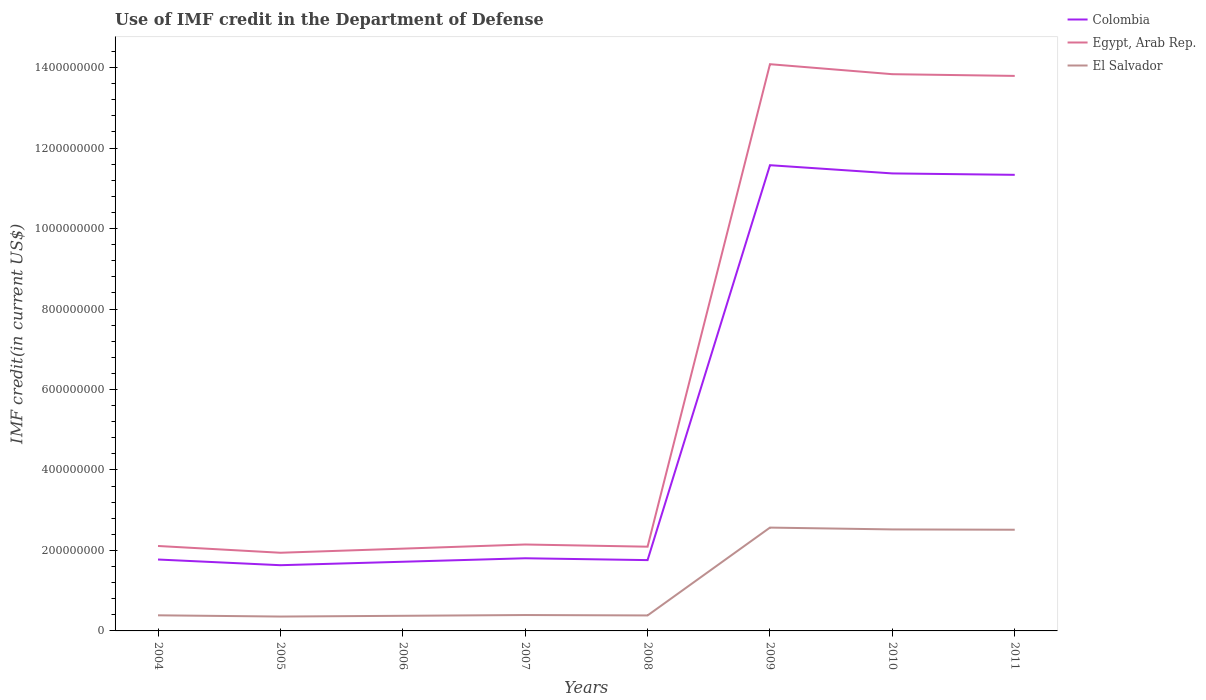Across all years, what is the maximum IMF credit in the Department of Defense in Colombia?
Make the answer very short. 1.63e+08. What is the total IMF credit in the Department of Defense in Egypt, Arab Rep. in the graph?
Offer a terse response. -4.88e+06. What is the difference between the highest and the second highest IMF credit in the Department of Defense in El Salvador?
Provide a short and direct response. 2.21e+08. Is the IMF credit in the Department of Defense in El Salvador strictly greater than the IMF credit in the Department of Defense in Egypt, Arab Rep. over the years?
Your answer should be compact. Yes. How many years are there in the graph?
Keep it short and to the point. 8. What is the difference between two consecutive major ticks on the Y-axis?
Make the answer very short. 2.00e+08. Does the graph contain any zero values?
Ensure brevity in your answer.  No. Does the graph contain grids?
Make the answer very short. No. What is the title of the graph?
Your answer should be very brief. Use of IMF credit in the Department of Defense. What is the label or title of the X-axis?
Your answer should be very brief. Years. What is the label or title of the Y-axis?
Offer a very short reply. IMF credit(in current US$). What is the IMF credit(in current US$) in Colombia in 2004?
Provide a succinct answer. 1.77e+08. What is the IMF credit(in current US$) of Egypt, Arab Rep. in 2004?
Your response must be concise. 2.11e+08. What is the IMF credit(in current US$) in El Salvador in 2004?
Offer a very short reply. 3.88e+07. What is the IMF credit(in current US$) in Colombia in 2005?
Your answer should be very brief. 1.63e+08. What is the IMF credit(in current US$) of Egypt, Arab Rep. in 2005?
Provide a short and direct response. 1.94e+08. What is the IMF credit(in current US$) of El Salvador in 2005?
Your response must be concise. 3.57e+07. What is the IMF credit(in current US$) of Colombia in 2006?
Your answer should be compact. 1.72e+08. What is the IMF credit(in current US$) of Egypt, Arab Rep. in 2006?
Offer a terse response. 2.04e+08. What is the IMF credit(in current US$) in El Salvador in 2006?
Provide a succinct answer. 3.76e+07. What is the IMF credit(in current US$) of Colombia in 2007?
Offer a terse response. 1.81e+08. What is the IMF credit(in current US$) of Egypt, Arab Rep. in 2007?
Your answer should be compact. 2.15e+08. What is the IMF credit(in current US$) of El Salvador in 2007?
Offer a very short reply. 3.95e+07. What is the IMF credit(in current US$) in Colombia in 2008?
Ensure brevity in your answer.  1.76e+08. What is the IMF credit(in current US$) of Egypt, Arab Rep. in 2008?
Offer a very short reply. 2.09e+08. What is the IMF credit(in current US$) of El Salvador in 2008?
Your answer should be very brief. 3.85e+07. What is the IMF credit(in current US$) of Colombia in 2009?
Ensure brevity in your answer.  1.16e+09. What is the IMF credit(in current US$) of Egypt, Arab Rep. in 2009?
Ensure brevity in your answer.  1.41e+09. What is the IMF credit(in current US$) of El Salvador in 2009?
Provide a succinct answer. 2.57e+08. What is the IMF credit(in current US$) of Colombia in 2010?
Your answer should be compact. 1.14e+09. What is the IMF credit(in current US$) in Egypt, Arab Rep. in 2010?
Make the answer very short. 1.38e+09. What is the IMF credit(in current US$) in El Salvador in 2010?
Give a very brief answer. 2.52e+08. What is the IMF credit(in current US$) of Colombia in 2011?
Keep it short and to the point. 1.13e+09. What is the IMF credit(in current US$) in Egypt, Arab Rep. in 2011?
Provide a short and direct response. 1.38e+09. What is the IMF credit(in current US$) of El Salvador in 2011?
Offer a terse response. 2.51e+08. Across all years, what is the maximum IMF credit(in current US$) of Colombia?
Ensure brevity in your answer.  1.16e+09. Across all years, what is the maximum IMF credit(in current US$) of Egypt, Arab Rep.?
Make the answer very short. 1.41e+09. Across all years, what is the maximum IMF credit(in current US$) of El Salvador?
Ensure brevity in your answer.  2.57e+08. Across all years, what is the minimum IMF credit(in current US$) of Colombia?
Make the answer very short. 1.63e+08. Across all years, what is the minimum IMF credit(in current US$) in Egypt, Arab Rep.?
Provide a short and direct response. 1.94e+08. Across all years, what is the minimum IMF credit(in current US$) in El Salvador?
Your answer should be compact. 3.57e+07. What is the total IMF credit(in current US$) in Colombia in the graph?
Provide a succinct answer. 4.30e+09. What is the total IMF credit(in current US$) in Egypt, Arab Rep. in the graph?
Your answer should be very brief. 5.21e+09. What is the total IMF credit(in current US$) in El Salvador in the graph?
Your answer should be compact. 9.51e+08. What is the difference between the IMF credit(in current US$) of Colombia in 2004 and that in 2005?
Give a very brief answer. 1.41e+07. What is the difference between the IMF credit(in current US$) in Egypt, Arab Rep. in 2004 and that in 2005?
Your answer should be compact. 1.68e+07. What is the difference between the IMF credit(in current US$) of El Salvador in 2004 and that in 2005?
Your answer should be compact. 3.09e+06. What is the difference between the IMF credit(in current US$) of Colombia in 2004 and that in 2006?
Ensure brevity in your answer.  5.56e+06. What is the difference between the IMF credit(in current US$) in Egypt, Arab Rep. in 2004 and that in 2006?
Provide a succinct answer. 6.61e+06. What is the difference between the IMF credit(in current US$) in El Salvador in 2004 and that in 2006?
Keep it short and to the point. 1.22e+06. What is the difference between the IMF credit(in current US$) in Colombia in 2004 and that in 2007?
Provide a short and direct response. -3.11e+06. What is the difference between the IMF credit(in current US$) of Egypt, Arab Rep. in 2004 and that in 2007?
Your answer should be very brief. -3.70e+06. What is the difference between the IMF credit(in current US$) of El Salvador in 2004 and that in 2007?
Give a very brief answer. -6.81e+05. What is the difference between the IMF credit(in current US$) of Colombia in 2004 and that in 2008?
Provide a short and direct response. 1.46e+06. What is the difference between the IMF credit(in current US$) of Egypt, Arab Rep. in 2004 and that in 2008?
Ensure brevity in your answer.  1.73e+06. What is the difference between the IMF credit(in current US$) in El Salvador in 2004 and that in 2008?
Ensure brevity in your answer.  3.18e+05. What is the difference between the IMF credit(in current US$) in Colombia in 2004 and that in 2009?
Make the answer very short. -9.80e+08. What is the difference between the IMF credit(in current US$) of Egypt, Arab Rep. in 2004 and that in 2009?
Offer a very short reply. -1.20e+09. What is the difference between the IMF credit(in current US$) in El Salvador in 2004 and that in 2009?
Ensure brevity in your answer.  -2.18e+08. What is the difference between the IMF credit(in current US$) of Colombia in 2004 and that in 2010?
Provide a short and direct response. -9.60e+08. What is the difference between the IMF credit(in current US$) in Egypt, Arab Rep. in 2004 and that in 2010?
Ensure brevity in your answer.  -1.17e+09. What is the difference between the IMF credit(in current US$) in El Salvador in 2004 and that in 2010?
Keep it short and to the point. -2.13e+08. What is the difference between the IMF credit(in current US$) of Colombia in 2004 and that in 2011?
Your answer should be very brief. -9.56e+08. What is the difference between the IMF credit(in current US$) in Egypt, Arab Rep. in 2004 and that in 2011?
Make the answer very short. -1.17e+09. What is the difference between the IMF credit(in current US$) in El Salvador in 2004 and that in 2011?
Your answer should be compact. -2.13e+08. What is the difference between the IMF credit(in current US$) of Colombia in 2005 and that in 2006?
Keep it short and to the point. -8.58e+06. What is the difference between the IMF credit(in current US$) of Egypt, Arab Rep. in 2005 and that in 2006?
Ensure brevity in your answer.  -1.02e+07. What is the difference between the IMF credit(in current US$) of El Salvador in 2005 and that in 2006?
Make the answer very short. -1.88e+06. What is the difference between the IMF credit(in current US$) of Colombia in 2005 and that in 2007?
Offer a terse response. -1.73e+07. What is the difference between the IMF credit(in current US$) of Egypt, Arab Rep. in 2005 and that in 2007?
Make the answer very short. -2.05e+07. What is the difference between the IMF credit(in current US$) in El Salvador in 2005 and that in 2007?
Ensure brevity in your answer.  -3.77e+06. What is the difference between the IMF credit(in current US$) in Colombia in 2005 and that in 2008?
Your answer should be very brief. -1.27e+07. What is the difference between the IMF credit(in current US$) in Egypt, Arab Rep. in 2005 and that in 2008?
Your response must be concise. -1.51e+07. What is the difference between the IMF credit(in current US$) in El Salvador in 2005 and that in 2008?
Offer a terse response. -2.77e+06. What is the difference between the IMF credit(in current US$) of Colombia in 2005 and that in 2009?
Offer a very short reply. -9.94e+08. What is the difference between the IMF credit(in current US$) in Egypt, Arab Rep. in 2005 and that in 2009?
Your answer should be very brief. -1.21e+09. What is the difference between the IMF credit(in current US$) in El Salvador in 2005 and that in 2009?
Keep it short and to the point. -2.21e+08. What is the difference between the IMF credit(in current US$) in Colombia in 2005 and that in 2010?
Make the answer very short. -9.74e+08. What is the difference between the IMF credit(in current US$) of Egypt, Arab Rep. in 2005 and that in 2010?
Offer a terse response. -1.19e+09. What is the difference between the IMF credit(in current US$) of El Salvador in 2005 and that in 2010?
Offer a terse response. -2.17e+08. What is the difference between the IMF credit(in current US$) in Colombia in 2005 and that in 2011?
Your answer should be compact. -9.70e+08. What is the difference between the IMF credit(in current US$) in Egypt, Arab Rep. in 2005 and that in 2011?
Provide a short and direct response. -1.19e+09. What is the difference between the IMF credit(in current US$) of El Salvador in 2005 and that in 2011?
Offer a terse response. -2.16e+08. What is the difference between the IMF credit(in current US$) in Colombia in 2006 and that in 2007?
Make the answer very short. -8.67e+06. What is the difference between the IMF credit(in current US$) of Egypt, Arab Rep. in 2006 and that in 2007?
Offer a very short reply. -1.03e+07. What is the difference between the IMF credit(in current US$) in El Salvador in 2006 and that in 2007?
Ensure brevity in your answer.  -1.90e+06. What is the difference between the IMF credit(in current US$) in Colombia in 2006 and that in 2008?
Your answer should be very brief. -4.10e+06. What is the difference between the IMF credit(in current US$) of Egypt, Arab Rep. in 2006 and that in 2008?
Give a very brief answer. -4.88e+06. What is the difference between the IMF credit(in current US$) of El Salvador in 2006 and that in 2008?
Your answer should be very brief. -8.97e+05. What is the difference between the IMF credit(in current US$) in Colombia in 2006 and that in 2009?
Provide a succinct answer. -9.86e+08. What is the difference between the IMF credit(in current US$) in Egypt, Arab Rep. in 2006 and that in 2009?
Offer a very short reply. -1.20e+09. What is the difference between the IMF credit(in current US$) in El Salvador in 2006 and that in 2009?
Keep it short and to the point. -2.19e+08. What is the difference between the IMF credit(in current US$) in Colombia in 2006 and that in 2010?
Make the answer very short. -9.65e+08. What is the difference between the IMF credit(in current US$) in Egypt, Arab Rep. in 2006 and that in 2010?
Offer a terse response. -1.18e+09. What is the difference between the IMF credit(in current US$) of El Salvador in 2006 and that in 2010?
Ensure brevity in your answer.  -2.15e+08. What is the difference between the IMF credit(in current US$) of Colombia in 2006 and that in 2011?
Ensure brevity in your answer.  -9.62e+08. What is the difference between the IMF credit(in current US$) in Egypt, Arab Rep. in 2006 and that in 2011?
Your response must be concise. -1.17e+09. What is the difference between the IMF credit(in current US$) in El Salvador in 2006 and that in 2011?
Provide a succinct answer. -2.14e+08. What is the difference between the IMF credit(in current US$) in Colombia in 2007 and that in 2008?
Offer a terse response. 4.57e+06. What is the difference between the IMF credit(in current US$) of Egypt, Arab Rep. in 2007 and that in 2008?
Keep it short and to the point. 5.43e+06. What is the difference between the IMF credit(in current US$) of El Salvador in 2007 and that in 2008?
Ensure brevity in your answer.  9.99e+05. What is the difference between the IMF credit(in current US$) of Colombia in 2007 and that in 2009?
Provide a succinct answer. -9.77e+08. What is the difference between the IMF credit(in current US$) of Egypt, Arab Rep. in 2007 and that in 2009?
Ensure brevity in your answer.  -1.19e+09. What is the difference between the IMF credit(in current US$) of El Salvador in 2007 and that in 2009?
Your response must be concise. -2.17e+08. What is the difference between the IMF credit(in current US$) of Colombia in 2007 and that in 2010?
Your response must be concise. -9.56e+08. What is the difference between the IMF credit(in current US$) of Egypt, Arab Rep. in 2007 and that in 2010?
Your answer should be very brief. -1.17e+09. What is the difference between the IMF credit(in current US$) of El Salvador in 2007 and that in 2010?
Give a very brief answer. -2.13e+08. What is the difference between the IMF credit(in current US$) in Colombia in 2007 and that in 2011?
Provide a short and direct response. -9.53e+08. What is the difference between the IMF credit(in current US$) in Egypt, Arab Rep. in 2007 and that in 2011?
Your answer should be very brief. -1.16e+09. What is the difference between the IMF credit(in current US$) in El Salvador in 2007 and that in 2011?
Provide a succinct answer. -2.12e+08. What is the difference between the IMF credit(in current US$) in Colombia in 2008 and that in 2009?
Provide a succinct answer. -9.81e+08. What is the difference between the IMF credit(in current US$) in Egypt, Arab Rep. in 2008 and that in 2009?
Make the answer very short. -1.20e+09. What is the difference between the IMF credit(in current US$) of El Salvador in 2008 and that in 2009?
Your answer should be very brief. -2.18e+08. What is the difference between the IMF credit(in current US$) of Colombia in 2008 and that in 2010?
Offer a terse response. -9.61e+08. What is the difference between the IMF credit(in current US$) of Egypt, Arab Rep. in 2008 and that in 2010?
Offer a very short reply. -1.17e+09. What is the difference between the IMF credit(in current US$) in El Salvador in 2008 and that in 2010?
Give a very brief answer. -2.14e+08. What is the difference between the IMF credit(in current US$) in Colombia in 2008 and that in 2011?
Your answer should be very brief. -9.58e+08. What is the difference between the IMF credit(in current US$) of Egypt, Arab Rep. in 2008 and that in 2011?
Ensure brevity in your answer.  -1.17e+09. What is the difference between the IMF credit(in current US$) of El Salvador in 2008 and that in 2011?
Give a very brief answer. -2.13e+08. What is the difference between the IMF credit(in current US$) in Colombia in 2009 and that in 2010?
Offer a terse response. 2.04e+07. What is the difference between the IMF credit(in current US$) of Egypt, Arab Rep. in 2009 and that in 2010?
Your answer should be very brief. 2.49e+07. What is the difference between the IMF credit(in current US$) of El Salvador in 2009 and that in 2010?
Provide a short and direct response. 4.53e+06. What is the difference between the IMF credit(in current US$) in Colombia in 2009 and that in 2011?
Your answer should be compact. 2.39e+07. What is the difference between the IMF credit(in current US$) of Egypt, Arab Rep. in 2009 and that in 2011?
Offer a terse response. 2.91e+07. What is the difference between the IMF credit(in current US$) in El Salvador in 2009 and that in 2011?
Your answer should be very brief. 5.31e+06. What is the difference between the IMF credit(in current US$) in Colombia in 2010 and that in 2011?
Your answer should be very brief. 3.51e+06. What is the difference between the IMF credit(in current US$) in Egypt, Arab Rep. in 2010 and that in 2011?
Offer a terse response. 4.28e+06. What is the difference between the IMF credit(in current US$) of El Salvador in 2010 and that in 2011?
Ensure brevity in your answer.  7.80e+05. What is the difference between the IMF credit(in current US$) in Colombia in 2004 and the IMF credit(in current US$) in Egypt, Arab Rep. in 2005?
Your answer should be compact. -1.68e+07. What is the difference between the IMF credit(in current US$) in Colombia in 2004 and the IMF credit(in current US$) in El Salvador in 2005?
Your response must be concise. 1.42e+08. What is the difference between the IMF credit(in current US$) in Egypt, Arab Rep. in 2004 and the IMF credit(in current US$) in El Salvador in 2005?
Offer a very short reply. 1.75e+08. What is the difference between the IMF credit(in current US$) in Colombia in 2004 and the IMF credit(in current US$) in Egypt, Arab Rep. in 2006?
Provide a succinct answer. -2.70e+07. What is the difference between the IMF credit(in current US$) of Colombia in 2004 and the IMF credit(in current US$) of El Salvador in 2006?
Make the answer very short. 1.40e+08. What is the difference between the IMF credit(in current US$) in Egypt, Arab Rep. in 2004 and the IMF credit(in current US$) in El Salvador in 2006?
Make the answer very short. 1.74e+08. What is the difference between the IMF credit(in current US$) in Colombia in 2004 and the IMF credit(in current US$) in Egypt, Arab Rep. in 2007?
Make the answer very short. -3.73e+07. What is the difference between the IMF credit(in current US$) in Colombia in 2004 and the IMF credit(in current US$) in El Salvador in 2007?
Offer a very short reply. 1.38e+08. What is the difference between the IMF credit(in current US$) in Egypt, Arab Rep. in 2004 and the IMF credit(in current US$) in El Salvador in 2007?
Offer a terse response. 1.72e+08. What is the difference between the IMF credit(in current US$) in Colombia in 2004 and the IMF credit(in current US$) in Egypt, Arab Rep. in 2008?
Ensure brevity in your answer.  -3.19e+07. What is the difference between the IMF credit(in current US$) of Colombia in 2004 and the IMF credit(in current US$) of El Salvador in 2008?
Your answer should be very brief. 1.39e+08. What is the difference between the IMF credit(in current US$) in Egypt, Arab Rep. in 2004 and the IMF credit(in current US$) in El Salvador in 2008?
Your answer should be compact. 1.73e+08. What is the difference between the IMF credit(in current US$) of Colombia in 2004 and the IMF credit(in current US$) of Egypt, Arab Rep. in 2009?
Give a very brief answer. -1.23e+09. What is the difference between the IMF credit(in current US$) in Colombia in 2004 and the IMF credit(in current US$) in El Salvador in 2009?
Provide a short and direct response. -7.93e+07. What is the difference between the IMF credit(in current US$) of Egypt, Arab Rep. in 2004 and the IMF credit(in current US$) of El Salvador in 2009?
Your answer should be compact. -4.57e+07. What is the difference between the IMF credit(in current US$) in Colombia in 2004 and the IMF credit(in current US$) in Egypt, Arab Rep. in 2010?
Your answer should be very brief. -1.21e+09. What is the difference between the IMF credit(in current US$) of Colombia in 2004 and the IMF credit(in current US$) of El Salvador in 2010?
Give a very brief answer. -7.48e+07. What is the difference between the IMF credit(in current US$) of Egypt, Arab Rep. in 2004 and the IMF credit(in current US$) of El Salvador in 2010?
Keep it short and to the point. -4.12e+07. What is the difference between the IMF credit(in current US$) of Colombia in 2004 and the IMF credit(in current US$) of Egypt, Arab Rep. in 2011?
Give a very brief answer. -1.20e+09. What is the difference between the IMF credit(in current US$) in Colombia in 2004 and the IMF credit(in current US$) in El Salvador in 2011?
Make the answer very short. -7.40e+07. What is the difference between the IMF credit(in current US$) in Egypt, Arab Rep. in 2004 and the IMF credit(in current US$) in El Salvador in 2011?
Your response must be concise. -4.04e+07. What is the difference between the IMF credit(in current US$) in Colombia in 2005 and the IMF credit(in current US$) in Egypt, Arab Rep. in 2006?
Keep it short and to the point. -4.12e+07. What is the difference between the IMF credit(in current US$) in Colombia in 2005 and the IMF credit(in current US$) in El Salvador in 2006?
Provide a short and direct response. 1.26e+08. What is the difference between the IMF credit(in current US$) in Egypt, Arab Rep. in 2005 and the IMF credit(in current US$) in El Salvador in 2006?
Your answer should be very brief. 1.57e+08. What is the difference between the IMF credit(in current US$) in Colombia in 2005 and the IMF credit(in current US$) in Egypt, Arab Rep. in 2007?
Your answer should be compact. -5.15e+07. What is the difference between the IMF credit(in current US$) in Colombia in 2005 and the IMF credit(in current US$) in El Salvador in 2007?
Offer a terse response. 1.24e+08. What is the difference between the IMF credit(in current US$) in Egypt, Arab Rep. in 2005 and the IMF credit(in current US$) in El Salvador in 2007?
Your answer should be very brief. 1.55e+08. What is the difference between the IMF credit(in current US$) in Colombia in 2005 and the IMF credit(in current US$) in Egypt, Arab Rep. in 2008?
Keep it short and to the point. -4.60e+07. What is the difference between the IMF credit(in current US$) in Colombia in 2005 and the IMF credit(in current US$) in El Salvador in 2008?
Your response must be concise. 1.25e+08. What is the difference between the IMF credit(in current US$) in Egypt, Arab Rep. in 2005 and the IMF credit(in current US$) in El Salvador in 2008?
Offer a terse response. 1.56e+08. What is the difference between the IMF credit(in current US$) of Colombia in 2005 and the IMF credit(in current US$) of Egypt, Arab Rep. in 2009?
Your answer should be compact. -1.25e+09. What is the difference between the IMF credit(in current US$) in Colombia in 2005 and the IMF credit(in current US$) in El Salvador in 2009?
Provide a succinct answer. -9.35e+07. What is the difference between the IMF credit(in current US$) in Egypt, Arab Rep. in 2005 and the IMF credit(in current US$) in El Salvador in 2009?
Your response must be concise. -6.25e+07. What is the difference between the IMF credit(in current US$) in Colombia in 2005 and the IMF credit(in current US$) in Egypt, Arab Rep. in 2010?
Your answer should be compact. -1.22e+09. What is the difference between the IMF credit(in current US$) of Colombia in 2005 and the IMF credit(in current US$) of El Salvador in 2010?
Keep it short and to the point. -8.89e+07. What is the difference between the IMF credit(in current US$) in Egypt, Arab Rep. in 2005 and the IMF credit(in current US$) in El Salvador in 2010?
Offer a very short reply. -5.80e+07. What is the difference between the IMF credit(in current US$) in Colombia in 2005 and the IMF credit(in current US$) in Egypt, Arab Rep. in 2011?
Your response must be concise. -1.22e+09. What is the difference between the IMF credit(in current US$) in Colombia in 2005 and the IMF credit(in current US$) in El Salvador in 2011?
Your answer should be compact. -8.82e+07. What is the difference between the IMF credit(in current US$) in Egypt, Arab Rep. in 2005 and the IMF credit(in current US$) in El Salvador in 2011?
Your answer should be very brief. -5.72e+07. What is the difference between the IMF credit(in current US$) of Colombia in 2006 and the IMF credit(in current US$) of Egypt, Arab Rep. in 2007?
Your answer should be compact. -4.29e+07. What is the difference between the IMF credit(in current US$) of Colombia in 2006 and the IMF credit(in current US$) of El Salvador in 2007?
Your answer should be very brief. 1.32e+08. What is the difference between the IMF credit(in current US$) in Egypt, Arab Rep. in 2006 and the IMF credit(in current US$) in El Salvador in 2007?
Provide a short and direct response. 1.65e+08. What is the difference between the IMF credit(in current US$) in Colombia in 2006 and the IMF credit(in current US$) in Egypt, Arab Rep. in 2008?
Give a very brief answer. -3.75e+07. What is the difference between the IMF credit(in current US$) of Colombia in 2006 and the IMF credit(in current US$) of El Salvador in 2008?
Your answer should be compact. 1.33e+08. What is the difference between the IMF credit(in current US$) in Egypt, Arab Rep. in 2006 and the IMF credit(in current US$) in El Salvador in 2008?
Your answer should be compact. 1.66e+08. What is the difference between the IMF credit(in current US$) of Colombia in 2006 and the IMF credit(in current US$) of Egypt, Arab Rep. in 2009?
Offer a very short reply. -1.24e+09. What is the difference between the IMF credit(in current US$) of Colombia in 2006 and the IMF credit(in current US$) of El Salvador in 2009?
Give a very brief answer. -8.49e+07. What is the difference between the IMF credit(in current US$) of Egypt, Arab Rep. in 2006 and the IMF credit(in current US$) of El Salvador in 2009?
Your answer should be very brief. -5.23e+07. What is the difference between the IMF credit(in current US$) in Colombia in 2006 and the IMF credit(in current US$) in Egypt, Arab Rep. in 2010?
Make the answer very short. -1.21e+09. What is the difference between the IMF credit(in current US$) of Colombia in 2006 and the IMF credit(in current US$) of El Salvador in 2010?
Make the answer very short. -8.04e+07. What is the difference between the IMF credit(in current US$) in Egypt, Arab Rep. in 2006 and the IMF credit(in current US$) in El Salvador in 2010?
Give a very brief answer. -4.78e+07. What is the difference between the IMF credit(in current US$) in Colombia in 2006 and the IMF credit(in current US$) in Egypt, Arab Rep. in 2011?
Your answer should be very brief. -1.21e+09. What is the difference between the IMF credit(in current US$) of Colombia in 2006 and the IMF credit(in current US$) of El Salvador in 2011?
Keep it short and to the point. -7.96e+07. What is the difference between the IMF credit(in current US$) of Egypt, Arab Rep. in 2006 and the IMF credit(in current US$) of El Salvador in 2011?
Make the answer very short. -4.70e+07. What is the difference between the IMF credit(in current US$) in Colombia in 2007 and the IMF credit(in current US$) in Egypt, Arab Rep. in 2008?
Your response must be concise. -2.88e+07. What is the difference between the IMF credit(in current US$) of Colombia in 2007 and the IMF credit(in current US$) of El Salvador in 2008?
Offer a terse response. 1.42e+08. What is the difference between the IMF credit(in current US$) of Egypt, Arab Rep. in 2007 and the IMF credit(in current US$) of El Salvador in 2008?
Give a very brief answer. 1.76e+08. What is the difference between the IMF credit(in current US$) of Colombia in 2007 and the IMF credit(in current US$) of Egypt, Arab Rep. in 2009?
Offer a terse response. -1.23e+09. What is the difference between the IMF credit(in current US$) in Colombia in 2007 and the IMF credit(in current US$) in El Salvador in 2009?
Ensure brevity in your answer.  -7.62e+07. What is the difference between the IMF credit(in current US$) in Egypt, Arab Rep. in 2007 and the IMF credit(in current US$) in El Salvador in 2009?
Give a very brief answer. -4.20e+07. What is the difference between the IMF credit(in current US$) of Colombia in 2007 and the IMF credit(in current US$) of Egypt, Arab Rep. in 2010?
Ensure brevity in your answer.  -1.20e+09. What is the difference between the IMF credit(in current US$) of Colombia in 2007 and the IMF credit(in current US$) of El Salvador in 2010?
Ensure brevity in your answer.  -7.17e+07. What is the difference between the IMF credit(in current US$) in Egypt, Arab Rep. in 2007 and the IMF credit(in current US$) in El Salvador in 2010?
Offer a terse response. -3.75e+07. What is the difference between the IMF credit(in current US$) of Colombia in 2007 and the IMF credit(in current US$) of Egypt, Arab Rep. in 2011?
Provide a succinct answer. -1.20e+09. What is the difference between the IMF credit(in current US$) in Colombia in 2007 and the IMF credit(in current US$) in El Salvador in 2011?
Your answer should be compact. -7.09e+07. What is the difference between the IMF credit(in current US$) in Egypt, Arab Rep. in 2007 and the IMF credit(in current US$) in El Salvador in 2011?
Offer a very short reply. -3.67e+07. What is the difference between the IMF credit(in current US$) in Colombia in 2008 and the IMF credit(in current US$) in Egypt, Arab Rep. in 2009?
Your answer should be compact. -1.23e+09. What is the difference between the IMF credit(in current US$) in Colombia in 2008 and the IMF credit(in current US$) in El Salvador in 2009?
Your response must be concise. -8.08e+07. What is the difference between the IMF credit(in current US$) of Egypt, Arab Rep. in 2008 and the IMF credit(in current US$) of El Salvador in 2009?
Ensure brevity in your answer.  -4.74e+07. What is the difference between the IMF credit(in current US$) in Colombia in 2008 and the IMF credit(in current US$) in Egypt, Arab Rep. in 2010?
Offer a very short reply. -1.21e+09. What is the difference between the IMF credit(in current US$) of Colombia in 2008 and the IMF credit(in current US$) of El Salvador in 2010?
Make the answer very short. -7.63e+07. What is the difference between the IMF credit(in current US$) of Egypt, Arab Rep. in 2008 and the IMF credit(in current US$) of El Salvador in 2010?
Your answer should be compact. -4.29e+07. What is the difference between the IMF credit(in current US$) in Colombia in 2008 and the IMF credit(in current US$) in Egypt, Arab Rep. in 2011?
Keep it short and to the point. -1.20e+09. What is the difference between the IMF credit(in current US$) of Colombia in 2008 and the IMF credit(in current US$) of El Salvador in 2011?
Ensure brevity in your answer.  -7.55e+07. What is the difference between the IMF credit(in current US$) of Egypt, Arab Rep. in 2008 and the IMF credit(in current US$) of El Salvador in 2011?
Your answer should be compact. -4.21e+07. What is the difference between the IMF credit(in current US$) of Colombia in 2009 and the IMF credit(in current US$) of Egypt, Arab Rep. in 2010?
Your answer should be very brief. -2.26e+08. What is the difference between the IMF credit(in current US$) in Colombia in 2009 and the IMF credit(in current US$) in El Salvador in 2010?
Keep it short and to the point. 9.05e+08. What is the difference between the IMF credit(in current US$) in Egypt, Arab Rep. in 2009 and the IMF credit(in current US$) in El Salvador in 2010?
Your answer should be very brief. 1.16e+09. What is the difference between the IMF credit(in current US$) in Colombia in 2009 and the IMF credit(in current US$) in Egypt, Arab Rep. in 2011?
Provide a succinct answer. -2.22e+08. What is the difference between the IMF credit(in current US$) of Colombia in 2009 and the IMF credit(in current US$) of El Salvador in 2011?
Provide a succinct answer. 9.06e+08. What is the difference between the IMF credit(in current US$) in Egypt, Arab Rep. in 2009 and the IMF credit(in current US$) in El Salvador in 2011?
Make the answer very short. 1.16e+09. What is the difference between the IMF credit(in current US$) in Colombia in 2010 and the IMF credit(in current US$) in Egypt, Arab Rep. in 2011?
Offer a very short reply. -2.42e+08. What is the difference between the IMF credit(in current US$) in Colombia in 2010 and the IMF credit(in current US$) in El Salvador in 2011?
Your answer should be compact. 8.86e+08. What is the difference between the IMF credit(in current US$) of Egypt, Arab Rep. in 2010 and the IMF credit(in current US$) of El Salvador in 2011?
Keep it short and to the point. 1.13e+09. What is the average IMF credit(in current US$) of Colombia per year?
Provide a succinct answer. 5.37e+08. What is the average IMF credit(in current US$) of Egypt, Arab Rep. per year?
Your response must be concise. 6.51e+08. What is the average IMF credit(in current US$) of El Salvador per year?
Provide a short and direct response. 1.19e+08. In the year 2004, what is the difference between the IMF credit(in current US$) in Colombia and IMF credit(in current US$) in Egypt, Arab Rep.?
Give a very brief answer. -3.36e+07. In the year 2004, what is the difference between the IMF credit(in current US$) in Colombia and IMF credit(in current US$) in El Salvador?
Give a very brief answer. 1.39e+08. In the year 2004, what is the difference between the IMF credit(in current US$) of Egypt, Arab Rep. and IMF credit(in current US$) of El Salvador?
Your response must be concise. 1.72e+08. In the year 2005, what is the difference between the IMF credit(in current US$) of Colombia and IMF credit(in current US$) of Egypt, Arab Rep.?
Offer a very short reply. -3.09e+07. In the year 2005, what is the difference between the IMF credit(in current US$) of Colombia and IMF credit(in current US$) of El Salvador?
Offer a terse response. 1.28e+08. In the year 2005, what is the difference between the IMF credit(in current US$) in Egypt, Arab Rep. and IMF credit(in current US$) in El Salvador?
Make the answer very short. 1.59e+08. In the year 2006, what is the difference between the IMF credit(in current US$) in Colombia and IMF credit(in current US$) in Egypt, Arab Rep.?
Make the answer very short. -3.26e+07. In the year 2006, what is the difference between the IMF credit(in current US$) of Colombia and IMF credit(in current US$) of El Salvador?
Ensure brevity in your answer.  1.34e+08. In the year 2006, what is the difference between the IMF credit(in current US$) in Egypt, Arab Rep. and IMF credit(in current US$) in El Salvador?
Give a very brief answer. 1.67e+08. In the year 2007, what is the difference between the IMF credit(in current US$) in Colombia and IMF credit(in current US$) in Egypt, Arab Rep.?
Make the answer very short. -3.42e+07. In the year 2007, what is the difference between the IMF credit(in current US$) in Colombia and IMF credit(in current US$) in El Salvador?
Offer a very short reply. 1.41e+08. In the year 2007, what is the difference between the IMF credit(in current US$) in Egypt, Arab Rep. and IMF credit(in current US$) in El Salvador?
Ensure brevity in your answer.  1.75e+08. In the year 2008, what is the difference between the IMF credit(in current US$) of Colombia and IMF credit(in current US$) of Egypt, Arab Rep.?
Provide a succinct answer. -3.34e+07. In the year 2008, what is the difference between the IMF credit(in current US$) of Colombia and IMF credit(in current US$) of El Salvador?
Your response must be concise. 1.38e+08. In the year 2008, what is the difference between the IMF credit(in current US$) of Egypt, Arab Rep. and IMF credit(in current US$) of El Salvador?
Provide a short and direct response. 1.71e+08. In the year 2009, what is the difference between the IMF credit(in current US$) of Colombia and IMF credit(in current US$) of Egypt, Arab Rep.?
Offer a terse response. -2.51e+08. In the year 2009, what is the difference between the IMF credit(in current US$) of Colombia and IMF credit(in current US$) of El Salvador?
Your answer should be compact. 9.01e+08. In the year 2009, what is the difference between the IMF credit(in current US$) of Egypt, Arab Rep. and IMF credit(in current US$) of El Salvador?
Offer a terse response. 1.15e+09. In the year 2010, what is the difference between the IMF credit(in current US$) of Colombia and IMF credit(in current US$) of Egypt, Arab Rep.?
Offer a terse response. -2.47e+08. In the year 2010, what is the difference between the IMF credit(in current US$) of Colombia and IMF credit(in current US$) of El Salvador?
Offer a very short reply. 8.85e+08. In the year 2010, what is the difference between the IMF credit(in current US$) of Egypt, Arab Rep. and IMF credit(in current US$) of El Salvador?
Provide a short and direct response. 1.13e+09. In the year 2011, what is the difference between the IMF credit(in current US$) in Colombia and IMF credit(in current US$) in Egypt, Arab Rep.?
Ensure brevity in your answer.  -2.46e+08. In the year 2011, what is the difference between the IMF credit(in current US$) of Colombia and IMF credit(in current US$) of El Salvador?
Provide a short and direct response. 8.82e+08. In the year 2011, what is the difference between the IMF credit(in current US$) in Egypt, Arab Rep. and IMF credit(in current US$) in El Salvador?
Ensure brevity in your answer.  1.13e+09. What is the ratio of the IMF credit(in current US$) of Colombia in 2004 to that in 2005?
Provide a succinct answer. 1.09. What is the ratio of the IMF credit(in current US$) in Egypt, Arab Rep. in 2004 to that in 2005?
Your answer should be very brief. 1.09. What is the ratio of the IMF credit(in current US$) in El Salvador in 2004 to that in 2005?
Your answer should be very brief. 1.09. What is the ratio of the IMF credit(in current US$) in Colombia in 2004 to that in 2006?
Provide a succinct answer. 1.03. What is the ratio of the IMF credit(in current US$) of Egypt, Arab Rep. in 2004 to that in 2006?
Provide a short and direct response. 1.03. What is the ratio of the IMF credit(in current US$) of El Salvador in 2004 to that in 2006?
Give a very brief answer. 1.03. What is the ratio of the IMF credit(in current US$) of Colombia in 2004 to that in 2007?
Ensure brevity in your answer.  0.98. What is the ratio of the IMF credit(in current US$) in Egypt, Arab Rep. in 2004 to that in 2007?
Offer a very short reply. 0.98. What is the ratio of the IMF credit(in current US$) of El Salvador in 2004 to that in 2007?
Your response must be concise. 0.98. What is the ratio of the IMF credit(in current US$) of Colombia in 2004 to that in 2008?
Your response must be concise. 1.01. What is the ratio of the IMF credit(in current US$) of Egypt, Arab Rep. in 2004 to that in 2008?
Your answer should be very brief. 1.01. What is the ratio of the IMF credit(in current US$) in El Salvador in 2004 to that in 2008?
Offer a terse response. 1.01. What is the ratio of the IMF credit(in current US$) of Colombia in 2004 to that in 2009?
Your response must be concise. 0.15. What is the ratio of the IMF credit(in current US$) of Egypt, Arab Rep. in 2004 to that in 2009?
Give a very brief answer. 0.15. What is the ratio of the IMF credit(in current US$) of El Salvador in 2004 to that in 2009?
Make the answer very short. 0.15. What is the ratio of the IMF credit(in current US$) in Colombia in 2004 to that in 2010?
Provide a succinct answer. 0.16. What is the ratio of the IMF credit(in current US$) of Egypt, Arab Rep. in 2004 to that in 2010?
Your answer should be very brief. 0.15. What is the ratio of the IMF credit(in current US$) in El Salvador in 2004 to that in 2010?
Provide a succinct answer. 0.15. What is the ratio of the IMF credit(in current US$) in Colombia in 2004 to that in 2011?
Give a very brief answer. 0.16. What is the ratio of the IMF credit(in current US$) in Egypt, Arab Rep. in 2004 to that in 2011?
Your answer should be very brief. 0.15. What is the ratio of the IMF credit(in current US$) of El Salvador in 2004 to that in 2011?
Your response must be concise. 0.15. What is the ratio of the IMF credit(in current US$) in Colombia in 2005 to that in 2006?
Your answer should be very brief. 0.95. What is the ratio of the IMF credit(in current US$) in Egypt, Arab Rep. in 2005 to that in 2006?
Keep it short and to the point. 0.95. What is the ratio of the IMF credit(in current US$) of El Salvador in 2005 to that in 2006?
Make the answer very short. 0.95. What is the ratio of the IMF credit(in current US$) in Colombia in 2005 to that in 2007?
Your answer should be very brief. 0.9. What is the ratio of the IMF credit(in current US$) in Egypt, Arab Rep. in 2005 to that in 2007?
Make the answer very short. 0.9. What is the ratio of the IMF credit(in current US$) in El Salvador in 2005 to that in 2007?
Make the answer very short. 0.9. What is the ratio of the IMF credit(in current US$) of Colombia in 2005 to that in 2008?
Offer a terse response. 0.93. What is the ratio of the IMF credit(in current US$) in Egypt, Arab Rep. in 2005 to that in 2008?
Make the answer very short. 0.93. What is the ratio of the IMF credit(in current US$) in El Salvador in 2005 to that in 2008?
Your answer should be compact. 0.93. What is the ratio of the IMF credit(in current US$) of Colombia in 2005 to that in 2009?
Provide a short and direct response. 0.14. What is the ratio of the IMF credit(in current US$) in Egypt, Arab Rep. in 2005 to that in 2009?
Offer a terse response. 0.14. What is the ratio of the IMF credit(in current US$) in El Salvador in 2005 to that in 2009?
Your answer should be very brief. 0.14. What is the ratio of the IMF credit(in current US$) in Colombia in 2005 to that in 2010?
Your response must be concise. 0.14. What is the ratio of the IMF credit(in current US$) of Egypt, Arab Rep. in 2005 to that in 2010?
Your answer should be very brief. 0.14. What is the ratio of the IMF credit(in current US$) in El Salvador in 2005 to that in 2010?
Provide a short and direct response. 0.14. What is the ratio of the IMF credit(in current US$) in Colombia in 2005 to that in 2011?
Your response must be concise. 0.14. What is the ratio of the IMF credit(in current US$) in Egypt, Arab Rep. in 2005 to that in 2011?
Provide a short and direct response. 0.14. What is the ratio of the IMF credit(in current US$) in El Salvador in 2005 to that in 2011?
Make the answer very short. 0.14. What is the ratio of the IMF credit(in current US$) of El Salvador in 2006 to that in 2007?
Give a very brief answer. 0.95. What is the ratio of the IMF credit(in current US$) of Colombia in 2006 to that in 2008?
Offer a very short reply. 0.98. What is the ratio of the IMF credit(in current US$) in Egypt, Arab Rep. in 2006 to that in 2008?
Offer a terse response. 0.98. What is the ratio of the IMF credit(in current US$) of El Salvador in 2006 to that in 2008?
Provide a succinct answer. 0.98. What is the ratio of the IMF credit(in current US$) of Colombia in 2006 to that in 2009?
Give a very brief answer. 0.15. What is the ratio of the IMF credit(in current US$) of Egypt, Arab Rep. in 2006 to that in 2009?
Make the answer very short. 0.15. What is the ratio of the IMF credit(in current US$) of El Salvador in 2006 to that in 2009?
Your answer should be compact. 0.15. What is the ratio of the IMF credit(in current US$) of Colombia in 2006 to that in 2010?
Make the answer very short. 0.15. What is the ratio of the IMF credit(in current US$) of Egypt, Arab Rep. in 2006 to that in 2010?
Provide a succinct answer. 0.15. What is the ratio of the IMF credit(in current US$) in El Salvador in 2006 to that in 2010?
Ensure brevity in your answer.  0.15. What is the ratio of the IMF credit(in current US$) of Colombia in 2006 to that in 2011?
Your response must be concise. 0.15. What is the ratio of the IMF credit(in current US$) in Egypt, Arab Rep. in 2006 to that in 2011?
Offer a very short reply. 0.15. What is the ratio of the IMF credit(in current US$) in El Salvador in 2006 to that in 2011?
Keep it short and to the point. 0.15. What is the ratio of the IMF credit(in current US$) in Colombia in 2007 to that in 2008?
Provide a short and direct response. 1.03. What is the ratio of the IMF credit(in current US$) of Egypt, Arab Rep. in 2007 to that in 2008?
Your answer should be very brief. 1.03. What is the ratio of the IMF credit(in current US$) in El Salvador in 2007 to that in 2008?
Ensure brevity in your answer.  1.03. What is the ratio of the IMF credit(in current US$) of Colombia in 2007 to that in 2009?
Keep it short and to the point. 0.16. What is the ratio of the IMF credit(in current US$) of Egypt, Arab Rep. in 2007 to that in 2009?
Keep it short and to the point. 0.15. What is the ratio of the IMF credit(in current US$) of El Salvador in 2007 to that in 2009?
Your answer should be very brief. 0.15. What is the ratio of the IMF credit(in current US$) of Colombia in 2007 to that in 2010?
Offer a terse response. 0.16. What is the ratio of the IMF credit(in current US$) of Egypt, Arab Rep. in 2007 to that in 2010?
Make the answer very short. 0.16. What is the ratio of the IMF credit(in current US$) of El Salvador in 2007 to that in 2010?
Offer a very short reply. 0.16. What is the ratio of the IMF credit(in current US$) of Colombia in 2007 to that in 2011?
Offer a very short reply. 0.16. What is the ratio of the IMF credit(in current US$) of Egypt, Arab Rep. in 2007 to that in 2011?
Keep it short and to the point. 0.16. What is the ratio of the IMF credit(in current US$) in El Salvador in 2007 to that in 2011?
Your response must be concise. 0.16. What is the ratio of the IMF credit(in current US$) in Colombia in 2008 to that in 2009?
Your response must be concise. 0.15. What is the ratio of the IMF credit(in current US$) in Egypt, Arab Rep. in 2008 to that in 2009?
Provide a succinct answer. 0.15. What is the ratio of the IMF credit(in current US$) of El Salvador in 2008 to that in 2009?
Provide a short and direct response. 0.15. What is the ratio of the IMF credit(in current US$) of Colombia in 2008 to that in 2010?
Your answer should be compact. 0.15. What is the ratio of the IMF credit(in current US$) of Egypt, Arab Rep. in 2008 to that in 2010?
Offer a terse response. 0.15. What is the ratio of the IMF credit(in current US$) of El Salvador in 2008 to that in 2010?
Your answer should be very brief. 0.15. What is the ratio of the IMF credit(in current US$) of Colombia in 2008 to that in 2011?
Ensure brevity in your answer.  0.16. What is the ratio of the IMF credit(in current US$) in Egypt, Arab Rep. in 2008 to that in 2011?
Provide a short and direct response. 0.15. What is the ratio of the IMF credit(in current US$) in El Salvador in 2008 to that in 2011?
Keep it short and to the point. 0.15. What is the ratio of the IMF credit(in current US$) in Colombia in 2009 to that in 2010?
Give a very brief answer. 1.02. What is the ratio of the IMF credit(in current US$) in Egypt, Arab Rep. in 2009 to that in 2010?
Provide a short and direct response. 1.02. What is the ratio of the IMF credit(in current US$) in El Salvador in 2009 to that in 2010?
Provide a short and direct response. 1.02. What is the ratio of the IMF credit(in current US$) in Colombia in 2009 to that in 2011?
Make the answer very short. 1.02. What is the ratio of the IMF credit(in current US$) of Egypt, Arab Rep. in 2009 to that in 2011?
Your answer should be compact. 1.02. What is the ratio of the IMF credit(in current US$) in El Salvador in 2009 to that in 2011?
Provide a succinct answer. 1.02. What is the difference between the highest and the second highest IMF credit(in current US$) of Colombia?
Your answer should be compact. 2.04e+07. What is the difference between the highest and the second highest IMF credit(in current US$) in Egypt, Arab Rep.?
Keep it short and to the point. 2.49e+07. What is the difference between the highest and the second highest IMF credit(in current US$) in El Salvador?
Give a very brief answer. 4.53e+06. What is the difference between the highest and the lowest IMF credit(in current US$) of Colombia?
Provide a short and direct response. 9.94e+08. What is the difference between the highest and the lowest IMF credit(in current US$) of Egypt, Arab Rep.?
Offer a very short reply. 1.21e+09. What is the difference between the highest and the lowest IMF credit(in current US$) of El Salvador?
Provide a short and direct response. 2.21e+08. 